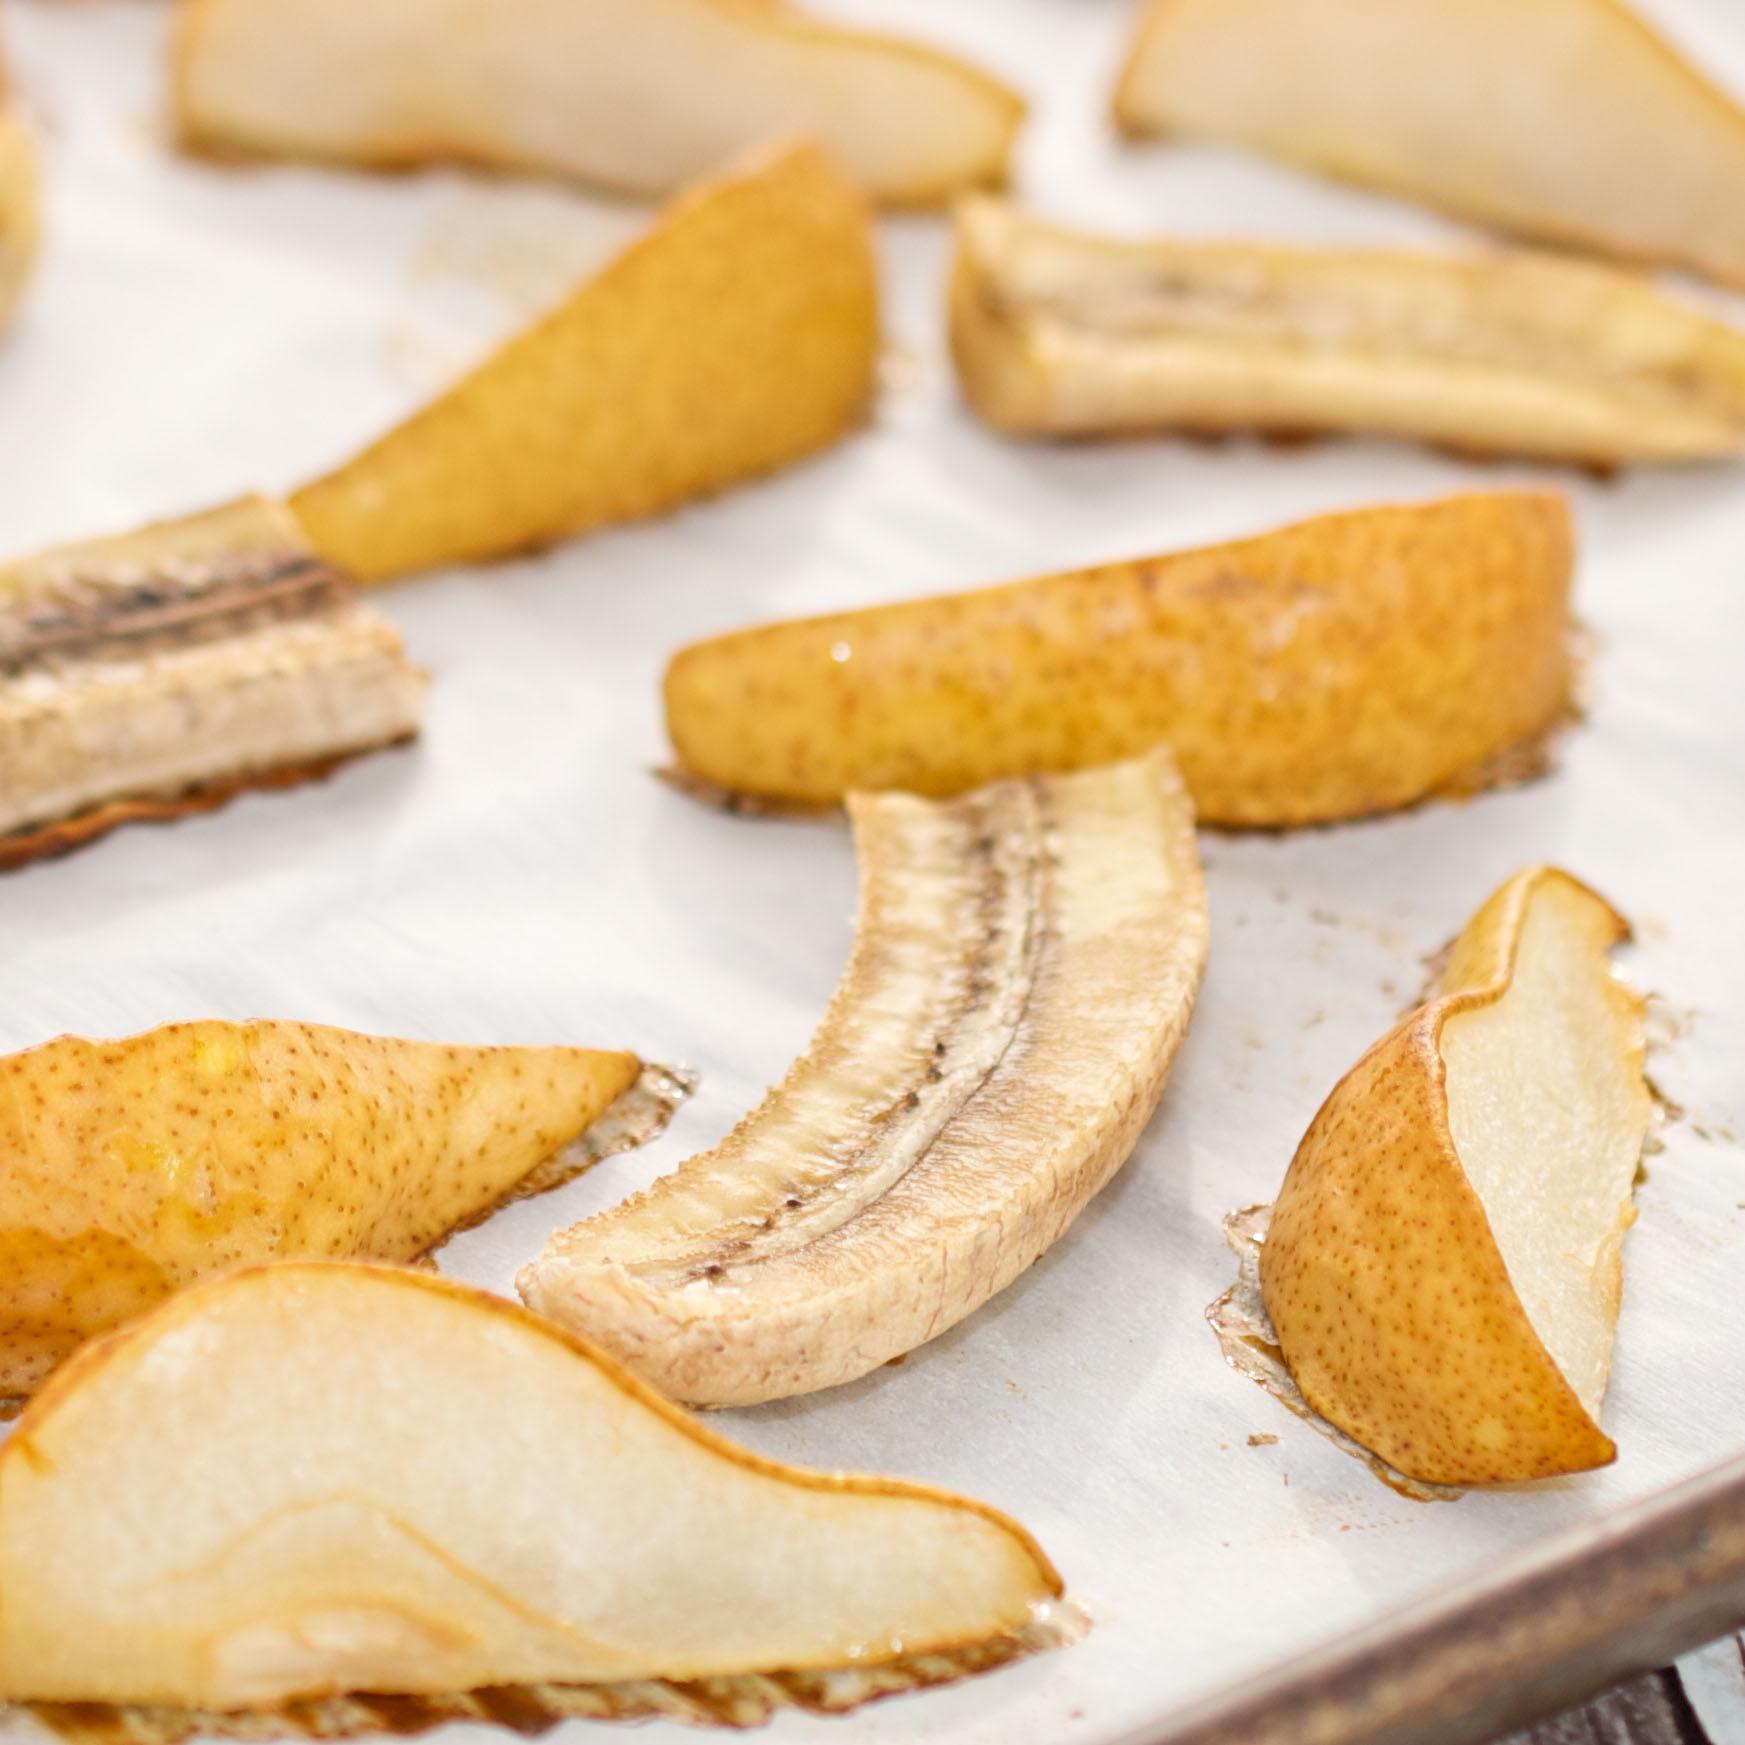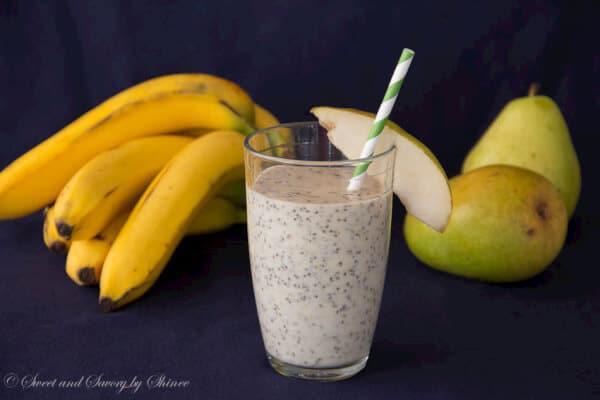The first image is the image on the left, the second image is the image on the right. Given the left and right images, does the statement "In one image, a glass of breakfast drink with a  straw is in front of whole bananas and at least one pear." hold true? Answer yes or no. Yes. The first image is the image on the left, the second image is the image on the right. Assess this claim about the two images: "An image shows intact banana, pear and beverage.". Correct or not? Answer yes or no. Yes. 